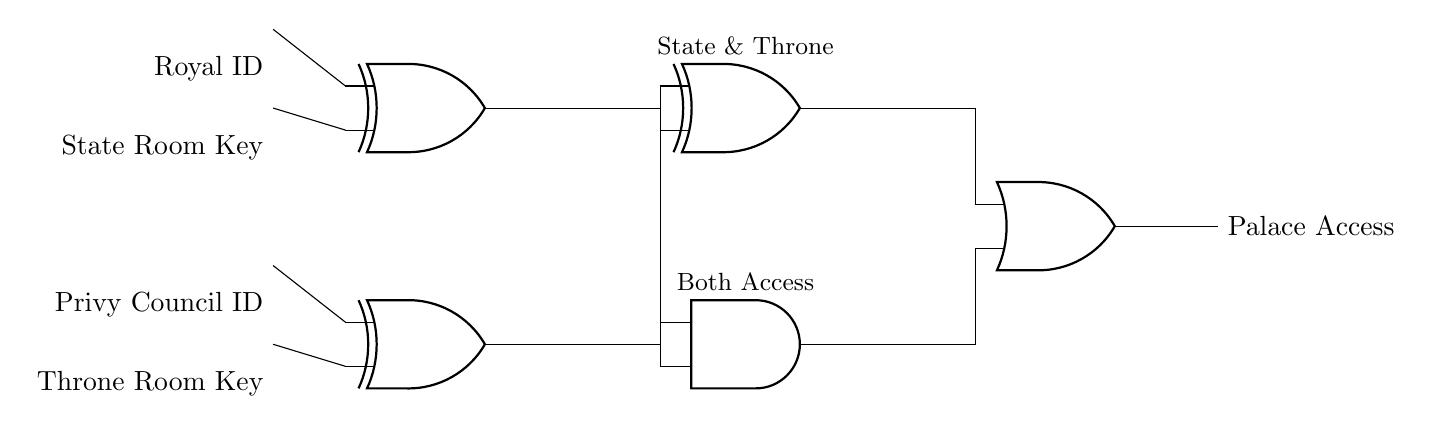What are the inputs for the first XOR gate? The first XOR gate has inputs labeled "Royal ID" and "State Room Key." These inputs are connected on the left side of the XOR gate.
Answer: Royal ID, State Room Key What is the type of the last gate in the circuit? The last gate shown in the circuit is labeled as an "OR" gate, which is positioned right after the outputs of the XOR and AND gates.
Answer: OR How many XOR gates are present in the circuit? There are three XOR gates present in the circuit, identified by their unique positions and labels in the diagram.
Answer: Three What does the output of the AND gate signify? The output of the AND gate indicates that both the inputs from the XOR gates must be active (true) in order to grant access, thus symbolizing "Both Access."
Answer: Both Access What is the output of the OR gate referred to as? The output of the OR gate is referred to as "Palace Access," which signifies the end result of the combined signals from the previous gates.
Answer: Palace Access How is the signal from the second XOR gate connected to the AND gate? The signal from the second XOR gate connects to the AND gate via a line that branches off, indicating that either of its outputs can contribute to the AND gate's inputs.
Answer: Via a line branching off 